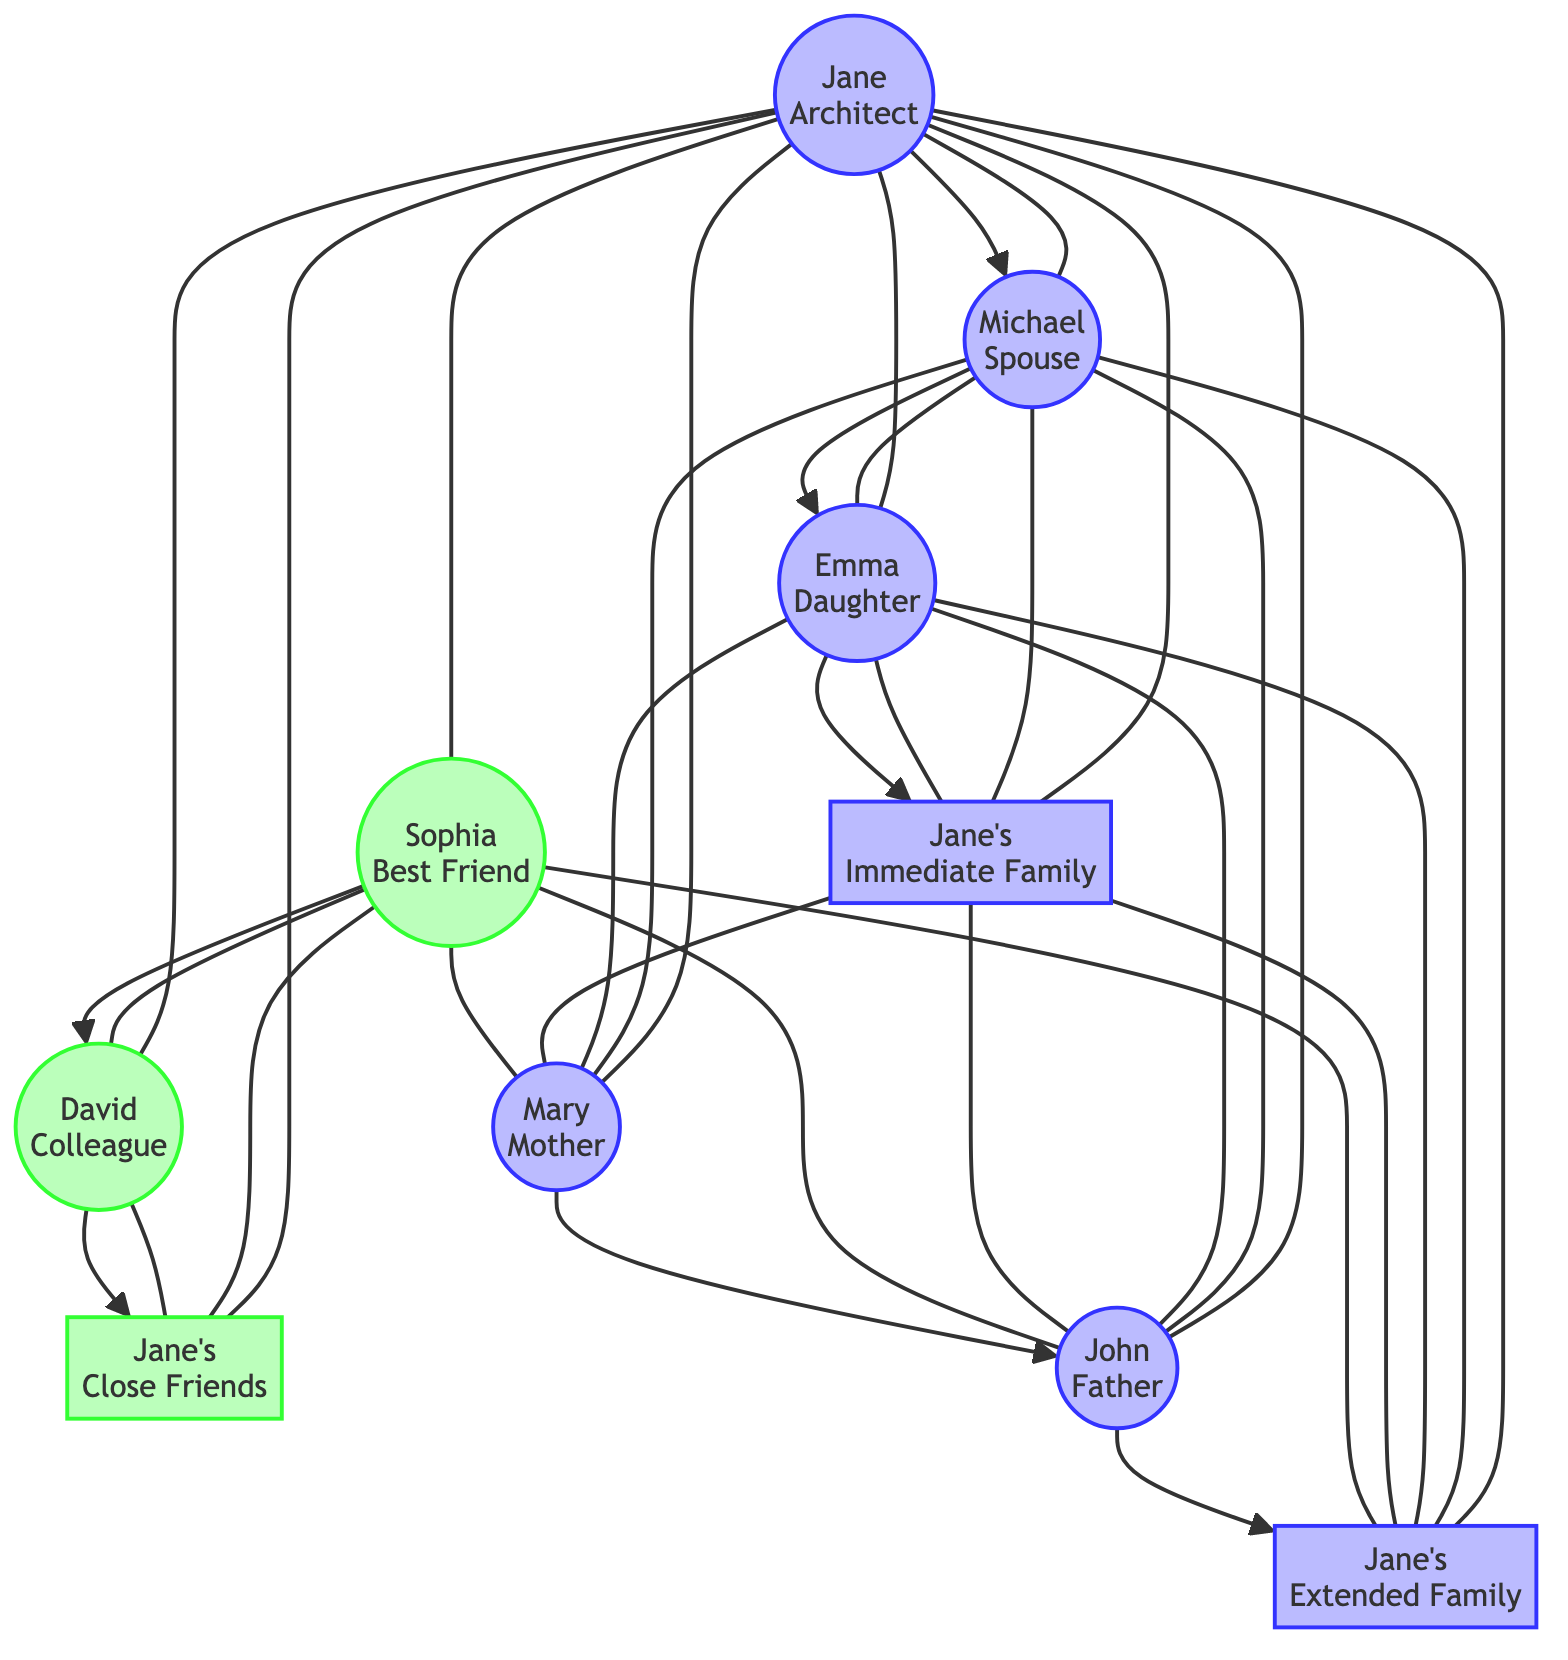What is Jane's relationship with Michael? In the diagram, there is an edge connecting Jane and Michael, which signifies a direct relationship. Since the label for Michael mentions "Spouse," it clearly indicates that Jane's relationship with Michael is that of a spouse.
Answer: Spouse How many family members are connected to Jane? To determine this, we look at all the nodes connected to Jane. The edges indicate connections to Michael, Emma, Lucas, Mary, John, and Grace, totaling six connections, which includes her spouse and children.
Answer: Six Which node represents Jane's best friend? The label for the node representing Jane’s best friend is "Sophia." The edge connects Jane directly to Sophia, indicating their close friendship.
Answer: Sophia How many total nodes are represented in the diagram? The diagram lists each individual in the nodes starting with Jane and includes all family members and friends, amounting to ten nodes (Jane, Michael, Emma, Lucas, Sophia, David, Olivia, Mary, John, Grace).
Answer: Ten Who are the children of Jane and Michael? The edges from Jane to Emma and Lucas indicate that both Emma and Lucas are directly connected to Jane, showing that they are her children. Given that Michael is her spouse, these two are also the children of Michael.
Answer: Emma, Lucas What is the relationship between Sophia and David? The diagram includes an edge connecting Sophia and David as they are both linked to Jane. However, there is no direct relationship indicated between them. This suggests they are more like acquaintances rather than having a close relationship.
Answer: Friends Is there a direct connection between Grace and Lucas? In the diagram, we need to check for an edge connecting Grace and Lucas. There is no direct edge between them, indicating they do not have a direct connection in the social support system represented here.
Answer: No Which two nodes are connected by the edge labeled "Neighbor"? The diagram has the label Olivia indicating her role as Jane's neighbor. The edge between Jane and Olivia signifies an additional form of social support. Other than Jane, Olivia's association is the closest relationship indicated.
Answer: Jane, Olivia 